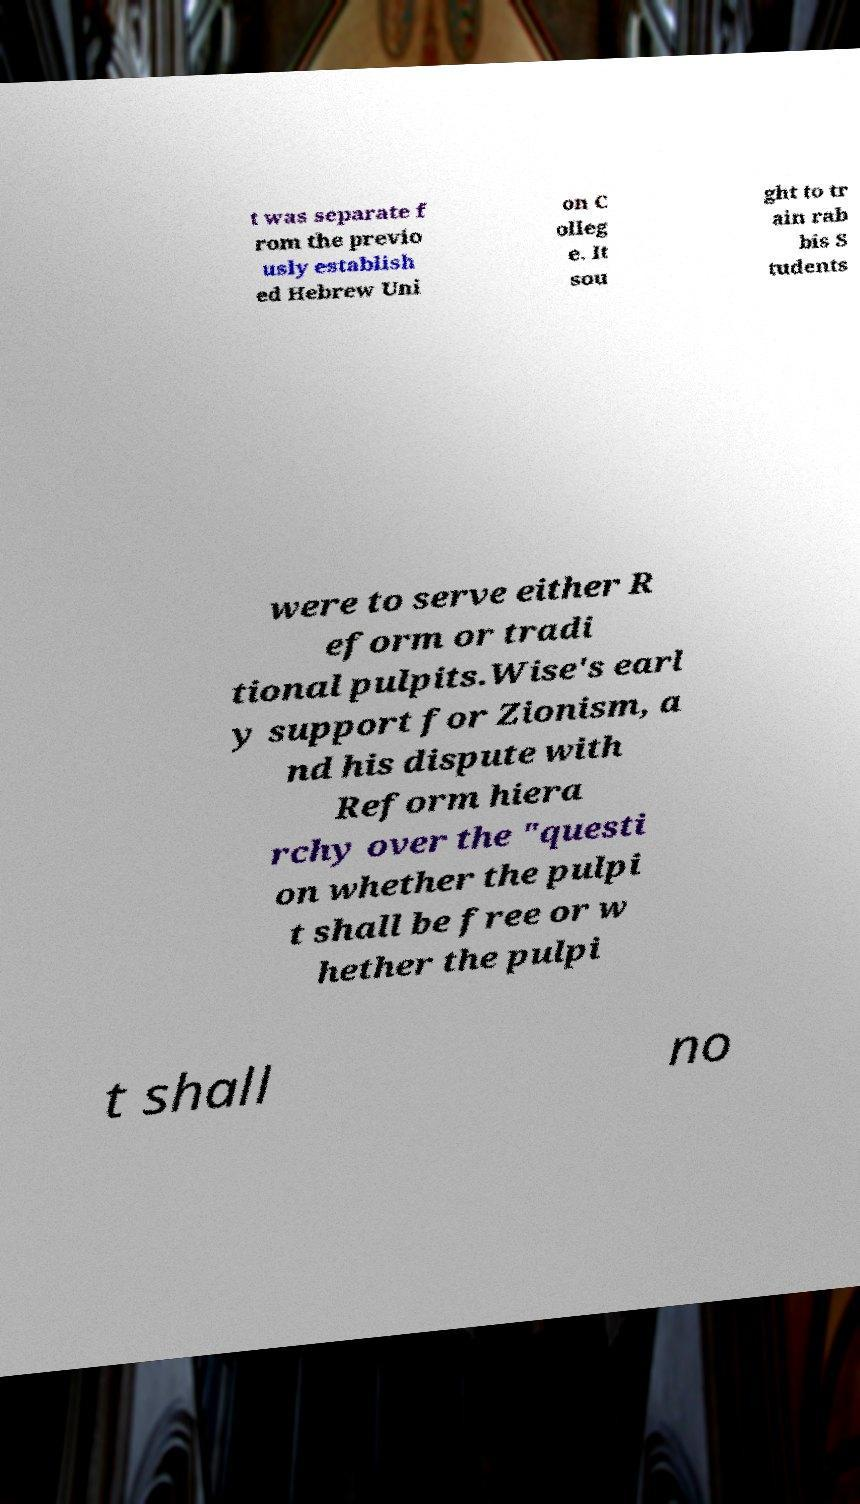There's text embedded in this image that I need extracted. Can you transcribe it verbatim? t was separate f rom the previo usly establish ed Hebrew Uni on C olleg e. It sou ght to tr ain rab bis S tudents were to serve either R eform or tradi tional pulpits.Wise's earl y support for Zionism, a nd his dispute with Reform hiera rchy over the "questi on whether the pulpi t shall be free or w hether the pulpi t shall no 